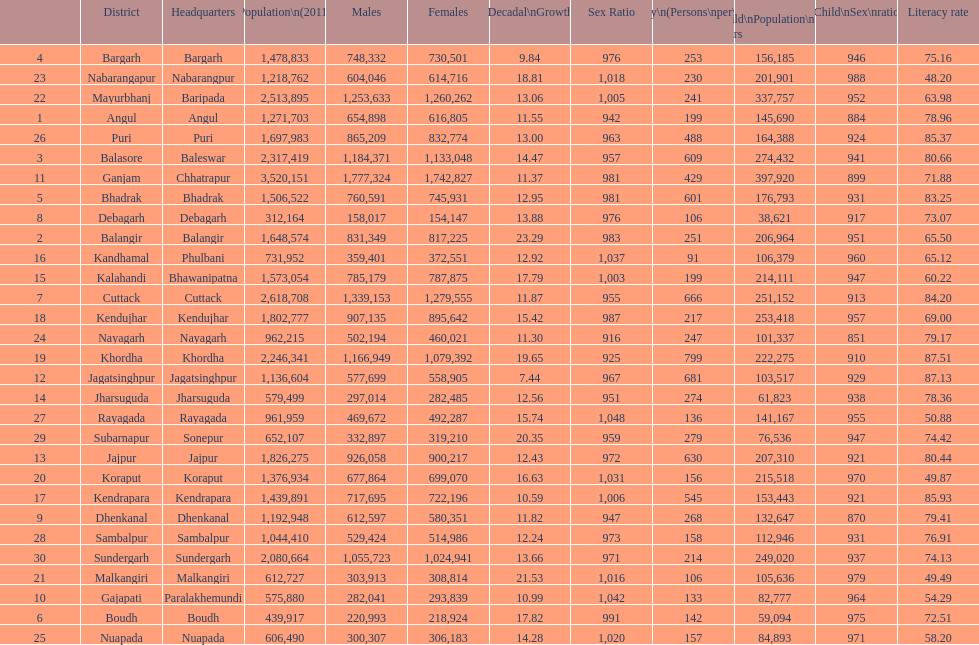Write the full table. {'header': ['', 'District', 'Headquarters', 'Population\\n(2011)', 'Males', 'Females', 'Percentage\\nDecadal\\nGrowth\\n2001-2011', 'Sex Ratio', 'Density\\n(Persons\\nper\\nkm2)', 'Child\\nPopulation\\n0–6 years', 'Child\\nSex\\nratio', 'Literacy rate'], 'rows': [['4', 'Bargarh', 'Bargarh', '1,478,833', '748,332', '730,501', '9.84', '976', '253', '156,185', '946', '75.16'], ['23', 'Nabarangapur', 'Nabarangpur', '1,218,762', '604,046', '614,716', '18.81', '1,018', '230', '201,901', '988', '48.20'], ['22', 'Mayurbhanj', 'Baripada', '2,513,895', '1,253,633', '1,260,262', '13.06', '1,005', '241', '337,757', '952', '63.98'], ['1', 'Angul', 'Angul', '1,271,703', '654,898', '616,805', '11.55', '942', '199', '145,690', '884', '78.96'], ['26', 'Puri', 'Puri', '1,697,983', '865,209', '832,774', '13.00', '963', '488', '164,388', '924', '85.37'], ['3', 'Balasore', 'Baleswar', '2,317,419', '1,184,371', '1,133,048', '14.47', '957', '609', '274,432', '941', '80.66'], ['11', 'Ganjam', 'Chhatrapur', '3,520,151', '1,777,324', '1,742,827', '11.37', '981', '429', '397,920', '899', '71.88'], ['5', 'Bhadrak', 'Bhadrak', '1,506,522', '760,591', '745,931', '12.95', '981', '601', '176,793', '931', '83.25'], ['8', 'Debagarh', 'Debagarh', '312,164', '158,017', '154,147', '13.88', '976', '106', '38,621', '917', '73.07'], ['2', 'Balangir', 'Balangir', '1,648,574', '831,349', '817,225', '23.29', '983', '251', '206,964', '951', '65.50'], ['16', 'Kandhamal', 'Phulbani', '731,952', '359,401', '372,551', '12.92', '1,037', '91', '106,379', '960', '65.12'], ['15', 'Kalahandi', 'Bhawanipatna', '1,573,054', '785,179', '787,875', '17.79', '1,003', '199', '214,111', '947', '60.22'], ['7', 'Cuttack', 'Cuttack', '2,618,708', '1,339,153', '1,279,555', '11.87', '955', '666', '251,152', '913', '84.20'], ['18', 'Kendujhar', 'Kendujhar', '1,802,777', '907,135', '895,642', '15.42', '987', '217', '253,418', '957', '69.00'], ['24', 'Nayagarh', 'Nayagarh', '962,215', '502,194', '460,021', '11.30', '916', '247', '101,337', '851', '79.17'], ['19', 'Khordha', 'Khordha', '2,246,341', '1,166,949', '1,079,392', '19.65', '925', '799', '222,275', '910', '87.51'], ['12', 'Jagatsinghpur', 'Jagatsinghpur', '1,136,604', '577,699', '558,905', '7.44', '967', '681', '103,517', '929', '87.13'], ['14', 'Jharsuguda', 'Jharsuguda', '579,499', '297,014', '282,485', '12.56', '951', '274', '61,823', '938', '78.36'], ['27', 'Rayagada', 'Rayagada', '961,959', '469,672', '492,287', '15.74', '1,048', '136', '141,167', '955', '50.88'], ['29', 'Subarnapur', 'Sonepur', '652,107', '332,897', '319,210', '20.35', '959', '279', '76,536', '947', '74.42'], ['13', 'Jajpur', 'Jajpur', '1,826,275', '926,058', '900,217', '12.43', '972', '630', '207,310', '921', '80.44'], ['20', 'Koraput', 'Koraput', '1,376,934', '677,864', '699,070', '16.63', '1,031', '156', '215,518', '970', '49.87'], ['17', 'Kendrapara', 'Kendrapara', '1,439,891', '717,695', '722,196', '10.59', '1,006', '545', '153,443', '921', '85.93'], ['9', 'Dhenkanal', 'Dhenkanal', '1,192,948', '612,597', '580,351', '11.82', '947', '268', '132,647', '870', '79.41'], ['28', 'Sambalpur', 'Sambalpur', '1,044,410', '529,424', '514,986', '12.24', '973', '158', '112,946', '931', '76.91'], ['30', 'Sundergarh', 'Sundergarh', '2,080,664', '1,055,723', '1,024,941', '13.66', '971', '214', '249,020', '937', '74.13'], ['21', 'Malkangiri', 'Malkangiri', '612,727', '303,913', '308,814', '21.53', '1,016', '106', '105,636', '979', '49.49'], ['10', 'Gajapati', 'Paralakhemundi', '575,880', '282,041', '293,839', '10.99', '1,042', '133', '82,777', '964', '54.29'], ['6', 'Boudh', 'Boudh', '439,917', '220,993', '218,924', '17.82', '991', '142', '59,094', '975', '72.51'], ['25', 'Nuapada', 'Nuapada', '606,490', '300,307', '306,183', '14.28', '1,020', '157', '84,893', '971', '58.20']]} In which district was the population density the highest per square kilometer? Khordha. 